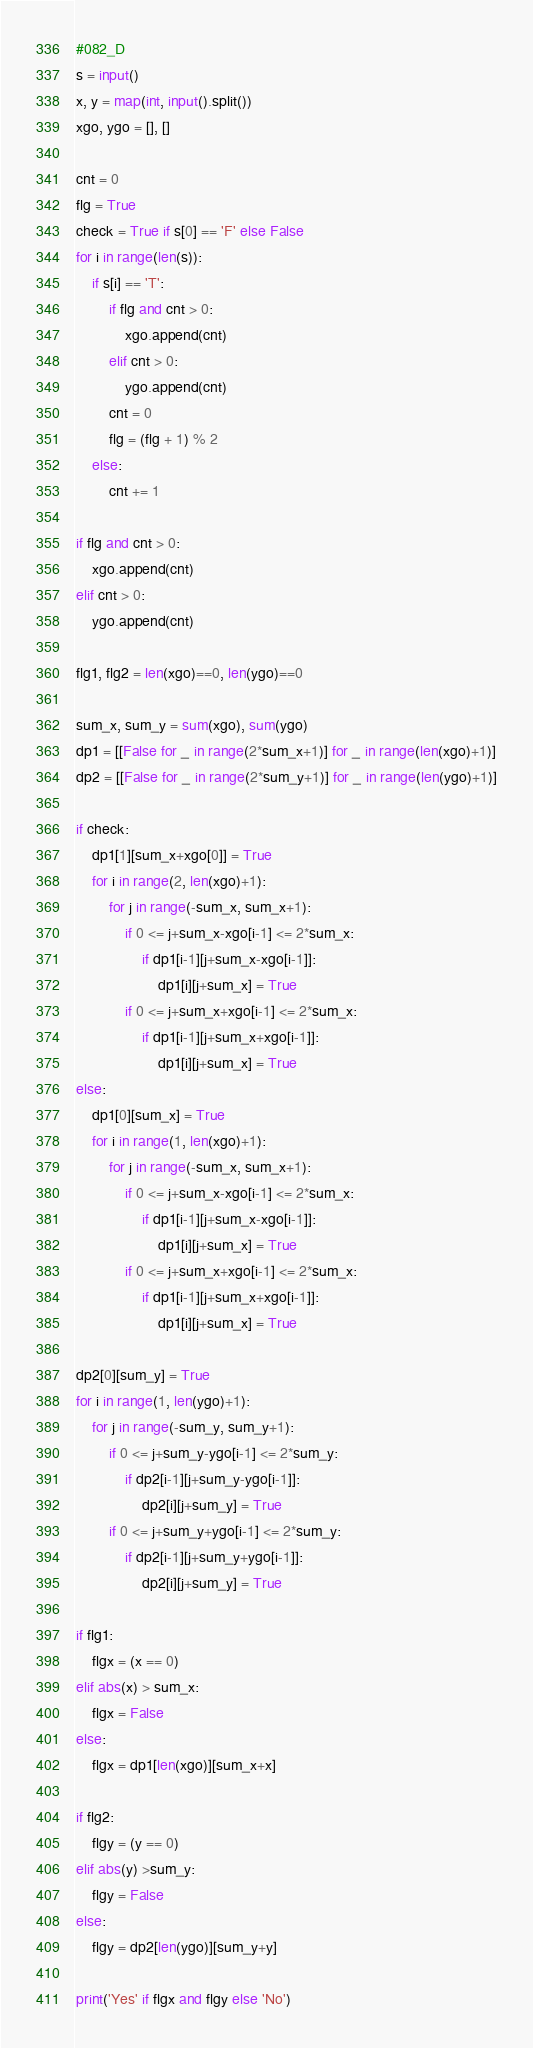<code> <loc_0><loc_0><loc_500><loc_500><_Python_>#082_D
s = input()
x, y = map(int, input().split())
xgo, ygo = [], []

cnt = 0
flg = True
check = True if s[0] == 'F' else False
for i in range(len(s)):
    if s[i] == 'T':
        if flg and cnt > 0:
            xgo.append(cnt)
        elif cnt > 0:
            ygo.append(cnt)
        cnt = 0
        flg = (flg + 1) % 2
    else:
        cnt += 1

if flg and cnt > 0:
    xgo.append(cnt)
elif cnt > 0:
    ygo.append(cnt)

flg1, flg2 = len(xgo)==0, len(ygo)==0

sum_x, sum_y = sum(xgo), sum(ygo)
dp1 = [[False for _ in range(2*sum_x+1)] for _ in range(len(xgo)+1)]
dp2 = [[False for _ in range(2*sum_y+1)] for _ in range(len(ygo)+1)]

if check:
    dp1[1][sum_x+xgo[0]] = True
    for i in range(2, len(xgo)+1):
        for j in range(-sum_x, sum_x+1):
            if 0 <= j+sum_x-xgo[i-1] <= 2*sum_x:
                if dp1[i-1][j+sum_x-xgo[i-1]]:
                    dp1[i][j+sum_x] = True
            if 0 <= j+sum_x+xgo[i-1] <= 2*sum_x:
                if dp1[i-1][j+sum_x+xgo[i-1]]:
                    dp1[i][j+sum_x] = True
else:
    dp1[0][sum_x] = True
    for i in range(1, len(xgo)+1):
        for j in range(-sum_x, sum_x+1):
            if 0 <= j+sum_x-xgo[i-1] <= 2*sum_x:
                if dp1[i-1][j+sum_x-xgo[i-1]]:
                    dp1[i][j+sum_x] = True
            if 0 <= j+sum_x+xgo[i-1] <= 2*sum_x:
                if dp1[i-1][j+sum_x+xgo[i-1]]:
                    dp1[i][j+sum_x] = True

dp2[0][sum_y] = True
for i in range(1, len(ygo)+1):
    for j in range(-sum_y, sum_y+1):
        if 0 <= j+sum_y-ygo[i-1] <= 2*sum_y:
            if dp2[i-1][j+sum_y-ygo[i-1]]:
                dp2[i][j+sum_y] = True
        if 0 <= j+sum_y+ygo[i-1] <= 2*sum_y:
            if dp2[i-1][j+sum_y+ygo[i-1]]:
                dp2[i][j+sum_y] = True
                
if flg1:
    flgx = (x == 0)
elif abs(x) > sum_x:
    flgx = False
else:
    flgx = dp1[len(xgo)][sum_x+x]
    
if flg2:
    flgy = (y == 0)
elif abs(y) >sum_y:
    flgy = False
else:
    flgy = dp2[len(ygo)][sum_y+y]
    
print('Yes' if flgx and flgy else 'No')</code> 